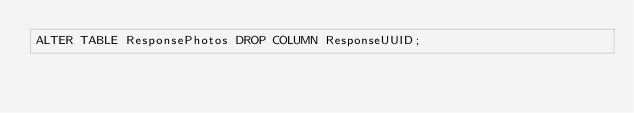Convert code to text. <code><loc_0><loc_0><loc_500><loc_500><_SQL_>ALTER TABLE ResponsePhotos DROP COLUMN ResponseUUID;</code> 